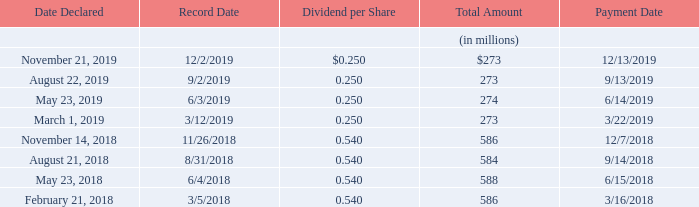(23) Dividends
Our Board of Directors declared the following dividends payable in 2019 and 2018:
The declaration of dividends is solely at the discretion of our Board of Directors, which may change or terminate our dividend practice at any time for any reason without prior notice. On February 27, 2020, our Board of Directors declared a quarterly cash dividend of $0.25 per share.
What can the Board of Directors do regarding the declaration of dividends? May change or terminate our dividend practice at any time for any reason without prior notice. What was the per share value of dividends declared on February 27, 2020? Quarterly cash dividend of $0.25 per share. What were the dates where the Board of Directors declared the dividends payable in the table? November 21, 2019, august 22, 2019, may 23, 2019, march 1, 2019, november 14, 2018, august 21, 2018, may 23, 2018, february 21, 2018. How many different dates did the Board of Directors declare the dividends payable in 2018 and 2019? November 21, 2019##August 22, 2019##May 23, 2019##March 1, 2019##November 14, 2018##August 21, 2018##May 23, 2018##February 21, 2018
Answer: 8. How many different dates declared had a dividend per share of $0.250 in 2018 and 2019? November 21, 2019##August 22, 2019##May 23, 2019##March 1, 2019
Answer: 4. What is the average total amount of dividend value for 2018 and 2019?
Answer scale should be: million. (273+273+274+273+586+584+588+586)/8
Answer: 429.62. 